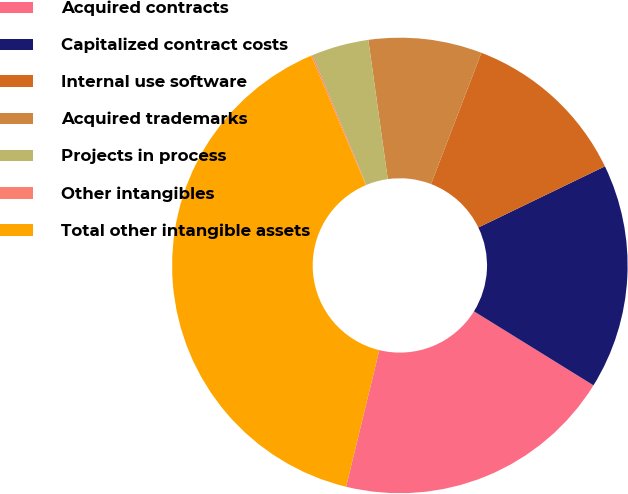<chart> <loc_0><loc_0><loc_500><loc_500><pie_chart><fcel>Acquired contracts<fcel>Capitalized contract costs<fcel>Internal use software<fcel>Acquired trademarks<fcel>Projects in process<fcel>Other intangibles<fcel>Total other intangible assets<nl><fcel>19.97%<fcel>15.99%<fcel>12.01%<fcel>8.04%<fcel>4.06%<fcel>0.09%<fcel>39.85%<nl></chart> 